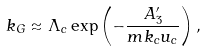Convert formula to latex. <formula><loc_0><loc_0><loc_500><loc_500>k _ { G } \approx \Lambda _ { c } \exp \left ( - \frac { A ^ { \prime } _ { 3 } } { m k _ { c } u _ { c } } \right ) ,</formula> 